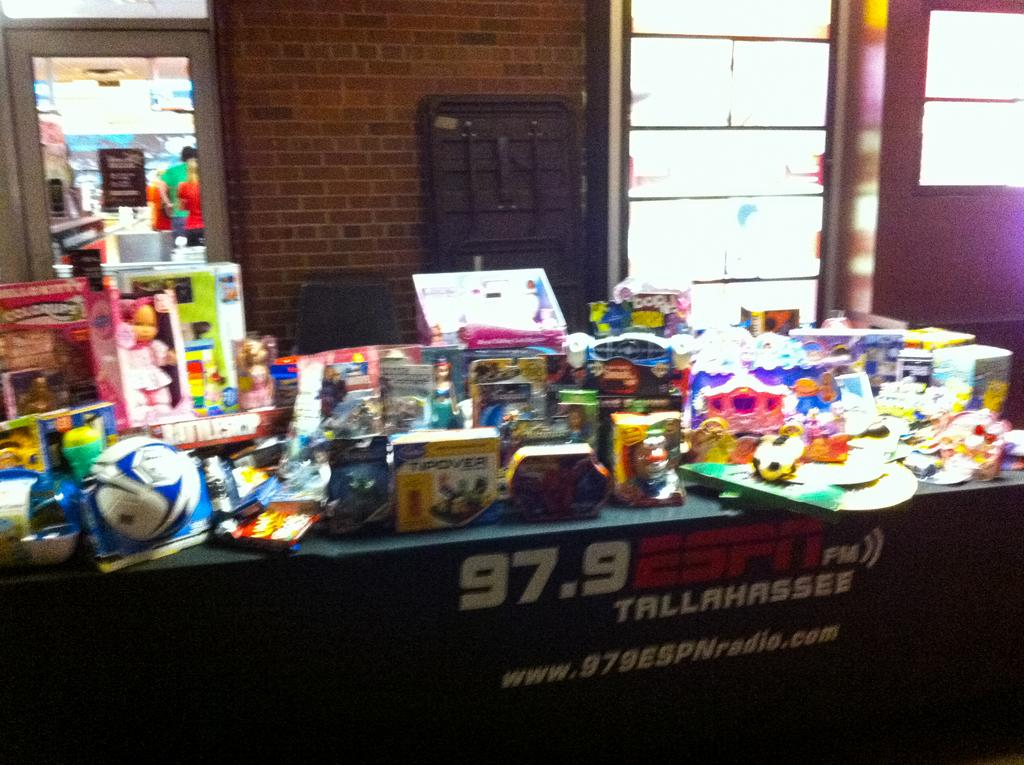Provide a one-sentence caption for the provided image. A table crowded with toys is sponsored by 97.9 ESPN FM out of Tallahassee. 